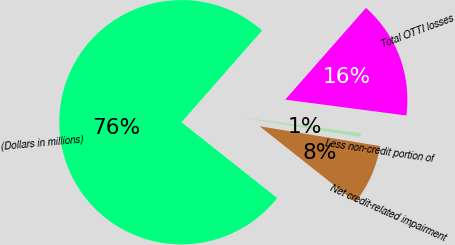<chart> <loc_0><loc_0><loc_500><loc_500><pie_chart><fcel>(Dollars in millions)<fcel>Total OTTI losses<fcel>Less non-credit portion of<fcel>Net credit-related impairment<nl><fcel>75.83%<fcel>15.59%<fcel>0.53%<fcel>8.06%<nl></chart> 